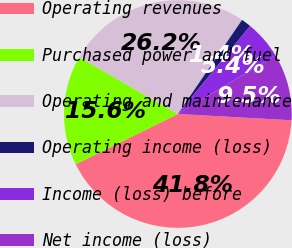<chart> <loc_0><loc_0><loc_500><loc_500><pie_chart><fcel>Operating revenues<fcel>Purchased power and fuel<fcel>Operating and maintenance<fcel>Operating income (loss)<fcel>Income (loss) before<fcel>Net income (loss)<nl><fcel>41.84%<fcel>15.59%<fcel>26.22%<fcel>1.41%<fcel>5.45%<fcel>9.49%<nl></chart> 